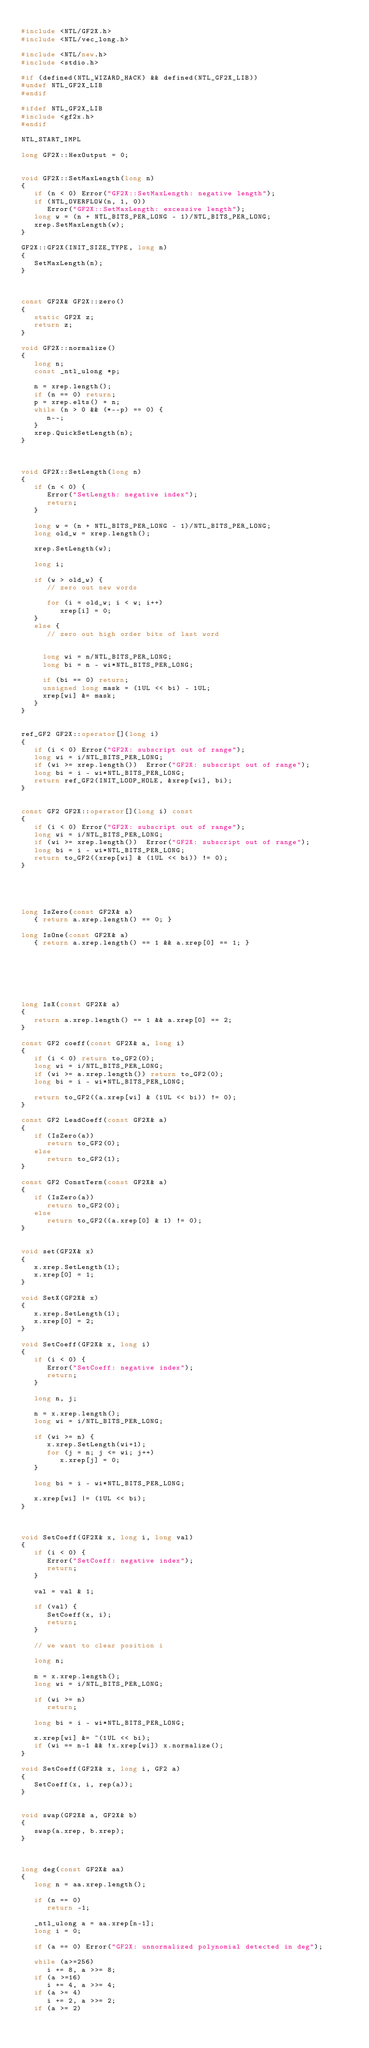Convert code to text. <code><loc_0><loc_0><loc_500><loc_500><_C++_>
#include <NTL/GF2X.h>
#include <NTL/vec_long.h>

#include <NTL/new.h>
#include <stdio.h>

#if (defined(NTL_WIZARD_HACK) && defined(NTL_GF2X_LIB))
#undef NTL_GF2X_LIB
#endif

#ifdef NTL_GF2X_LIB
#include <gf2x.h>
#endif

NTL_START_IMPL

long GF2X::HexOutput = 0;


void GF2X::SetMaxLength(long n)
{
   if (n < 0) Error("GF2X::SetMaxLength: negative length");
   if (NTL_OVERFLOW(n, 1, 0))
      Error("GF2X::SetMaxLength: excessive length");
   long w = (n + NTL_BITS_PER_LONG - 1)/NTL_BITS_PER_LONG;
   xrep.SetMaxLength(w);
}

GF2X::GF2X(INIT_SIZE_TYPE, long n)
{
   SetMaxLength(n);
}



const GF2X& GF2X::zero()
{
   static GF2X z;
   return z;
}

void GF2X::normalize()
{
   long n;
   const _ntl_ulong *p;

   n = xrep.length();
   if (n == 0) return;
   p = xrep.elts() + n;
   while (n > 0 && (*--p) == 0) {
      n--;
   }
   xrep.QuickSetLength(n);
}



void GF2X::SetLength(long n)
{
   if (n < 0) {
      Error("SetLength: negative index");
      return;
   }

   long w = (n + NTL_BITS_PER_LONG - 1)/NTL_BITS_PER_LONG;
   long old_w = xrep.length();

   xrep.SetLength(w);

   long i;

   if (w > old_w) {
      // zero out new words

      for (i = old_w; i < w; i++)
         xrep[i] = 0;
   }
   else {
      // zero out high order bits of last word


     long wi = n/NTL_BITS_PER_LONG;
     long bi = n - wi*NTL_BITS_PER_LONG;

     if (bi == 0) return;
     unsigned long mask = (1UL << bi) - 1UL;
     xrep[wi] &= mask;
   }
}


ref_GF2 GF2X::operator[](long i)
{
   if (i < 0) Error("GF2X: subscript out of range");
   long wi = i/NTL_BITS_PER_LONG;
   if (wi >= xrep.length())  Error("GF2X: subscript out of range");
   long bi = i - wi*NTL_BITS_PER_LONG;
   return ref_GF2(INIT_LOOP_HOLE, &xrep[wi], bi);
}


const GF2 GF2X::operator[](long i) const
{
   if (i < 0) Error("GF2X: subscript out of range");
   long wi = i/NTL_BITS_PER_LONG;
   if (wi >= xrep.length())  Error("GF2X: subscript out of range");
   long bi = i - wi*NTL_BITS_PER_LONG;
   return to_GF2((xrep[wi] & (1UL << bi)) != 0);
}





long IsZero(const GF2X& a) 
   { return a.xrep.length() == 0; }

long IsOne(const GF2X& a)
   { return a.xrep.length() == 1 && a.xrep[0] == 1; }







long IsX(const GF2X& a)
{
   return a.xrep.length() == 1 && a.xrep[0] == 2;
}

const GF2 coeff(const GF2X& a, long i)
{
   if (i < 0) return to_GF2(0);
   long wi = i/NTL_BITS_PER_LONG;
   if (wi >= a.xrep.length()) return to_GF2(0);
   long bi = i - wi*NTL_BITS_PER_LONG;

   return to_GF2((a.xrep[wi] & (1UL << bi)) != 0);
}

const GF2 LeadCoeff(const GF2X& a)
{
   if (IsZero(a))
      return to_GF2(0);
   else
      return to_GF2(1);
}

const GF2 ConstTerm(const GF2X& a)
{
   if (IsZero(a))
      return to_GF2(0);
   else
      return to_GF2((a.xrep[0] & 1) != 0);
}


void set(GF2X& x)
{
   x.xrep.SetLength(1);
   x.xrep[0] = 1;
}

void SetX(GF2X& x)
{
   x.xrep.SetLength(1);
   x.xrep[0] = 2;
}

void SetCoeff(GF2X& x, long i)
{
   if (i < 0) {
      Error("SetCoeff: negative index");
      return;
   }

   long n, j;

   n = x.xrep.length();
   long wi = i/NTL_BITS_PER_LONG;

   if (wi >= n) {
      x.xrep.SetLength(wi+1);
      for (j = n; j <= wi; j++)
         x.xrep[j] = 0;
   }

   long bi = i - wi*NTL_BITS_PER_LONG;

   x.xrep[wi] |= (1UL << bi);
}
   


void SetCoeff(GF2X& x, long i, long val)
{
   if (i < 0) {
      Error("SetCoeff: negative index");
      return;
   }

   val = val & 1;

   if (val) {
      SetCoeff(x, i);
      return;
   }

   // we want to clear position i

   long n;

   n = x.xrep.length();
   long wi = i/NTL_BITS_PER_LONG;

   if (wi >= n) 
      return;

   long bi = i - wi*NTL_BITS_PER_LONG;

   x.xrep[wi] &= ~(1UL << bi);
   if (wi == n-1 && !x.xrep[wi]) x.normalize();
}

void SetCoeff(GF2X& x, long i, GF2 a)
{
   SetCoeff(x, i, rep(a));
}


void swap(GF2X& a, GF2X& b)
{
   swap(a.xrep, b.xrep);
}



long deg(const GF2X& aa)
{
   long n = aa.xrep.length();

   if (n == 0)
      return -1;

   _ntl_ulong a = aa.xrep[n-1];
   long i = 0;

   if (a == 0) Error("GF2X: unnormalized polynomial detected in deg");

   while (a>=256)
      i += 8, a >>= 8;
   if (a >=16)
      i += 4, a >>= 4;
   if (a >= 4)
      i += 2, a >>= 2;
   if (a >= 2)</code> 